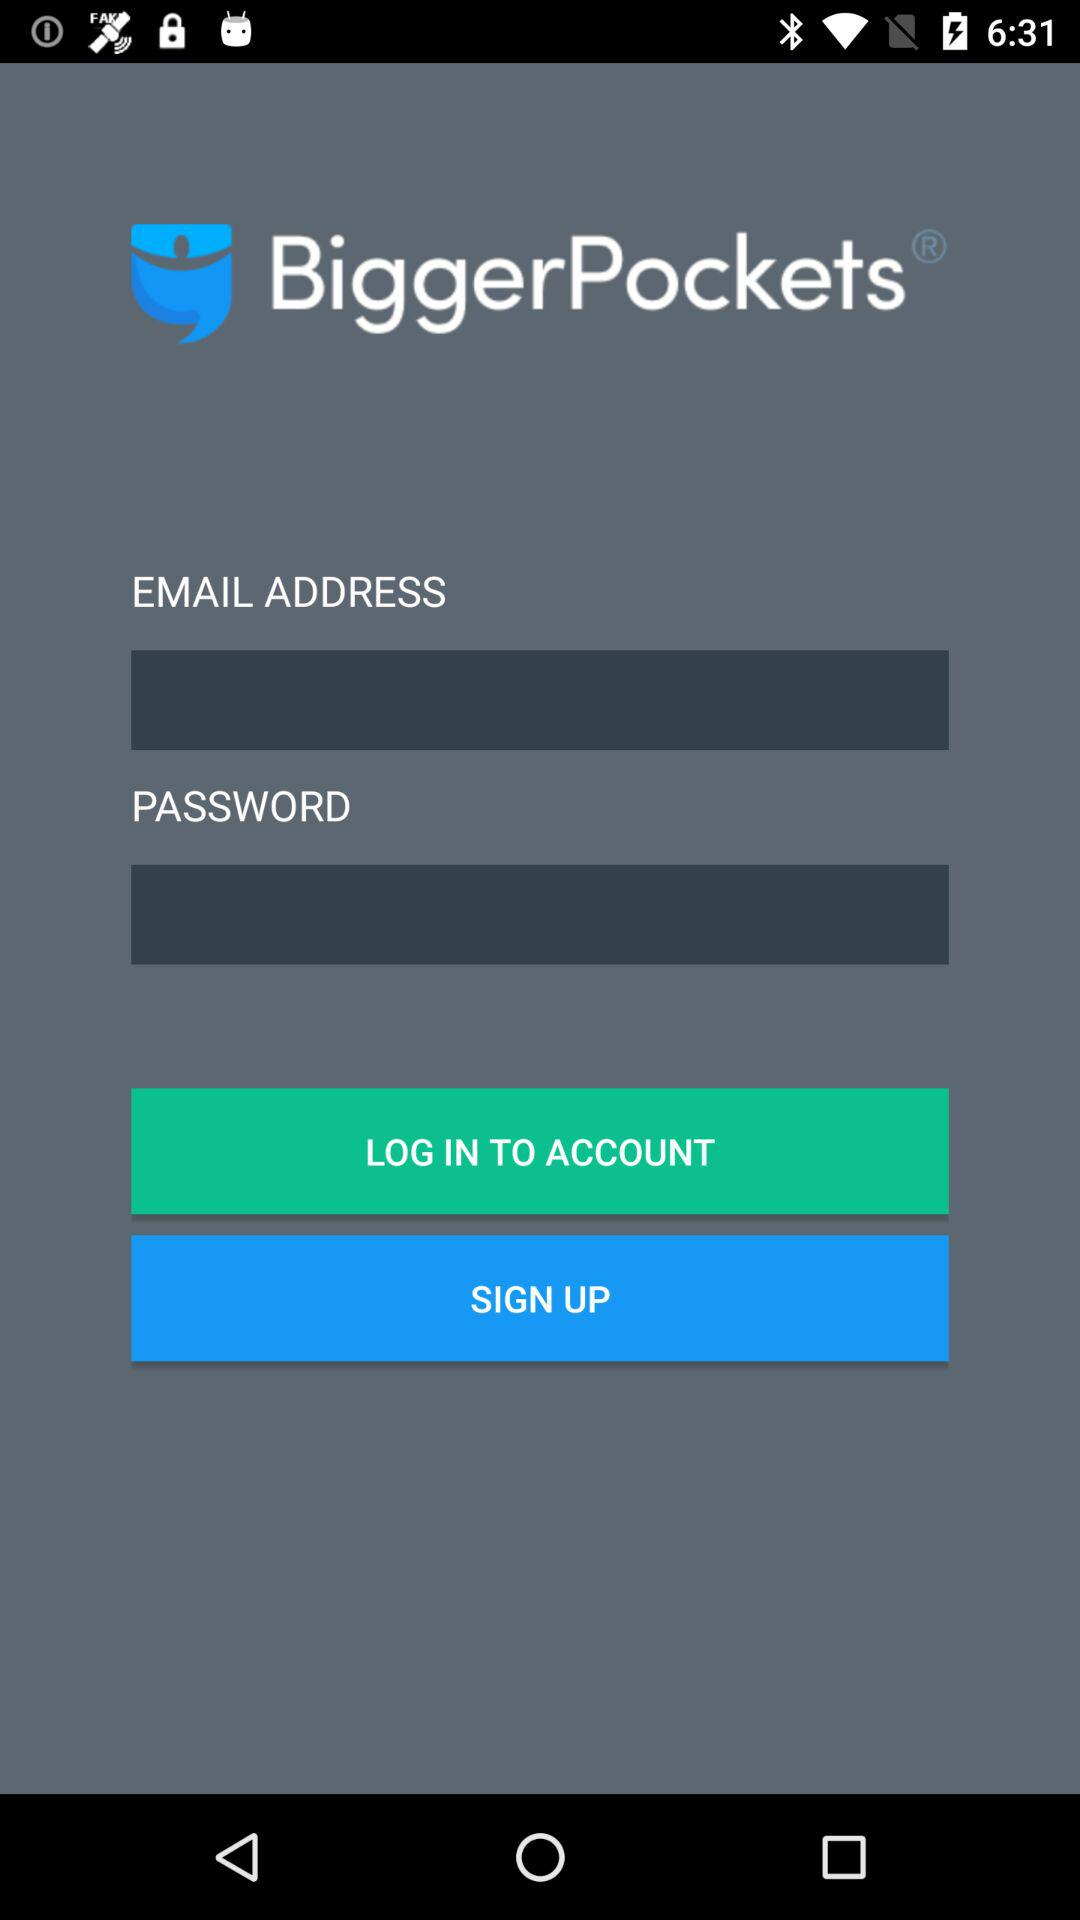What is the name of the application? The name of the application is "BiggerPockets". 